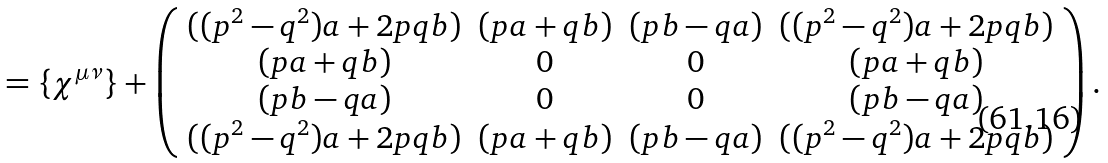Convert formula to latex. <formula><loc_0><loc_0><loc_500><loc_500>= \{ \chi ^ { \mu \nu } \} + \left ( \begin{array} { c c c c } { { ( ( p ^ { 2 } - q ^ { 2 } ) a + 2 p q b ) } } & { ( p a + q b ) } & { ( p b - q a ) } & { { ( ( p ^ { 2 } - q ^ { 2 } ) a + 2 p q b ) } } \\ { ( p a + q b ) } & { 0 } & { 0 } & { ( p a + q b ) } \\ { ( p b - q a ) } & { 0 } & { 0 } & { ( p b - q a ) } \\ { { ( ( p ^ { 2 } - q ^ { 2 } ) a + 2 p q b ) } } & { ( p a + q b ) } & { ( p b - q a ) } & { { ( ( p ^ { 2 } - q ^ { 2 } ) a + 2 p q b ) } } \end{array} \right ) .</formula> 